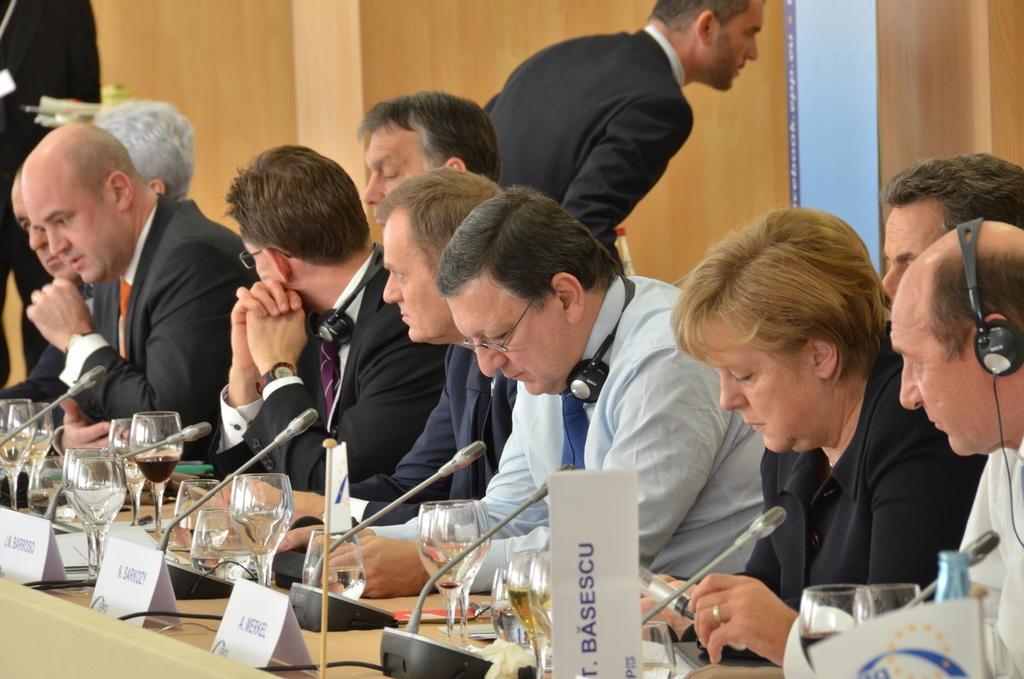Can you describe this image briefly? At the bottom of the image there is a table. On the table there are name boards, glasses with drinks, mics and some other things. Behind the table there are few people sitting. And there are three persons with headphones. Behind them there is a man standing. And also there is wall with pillars. 